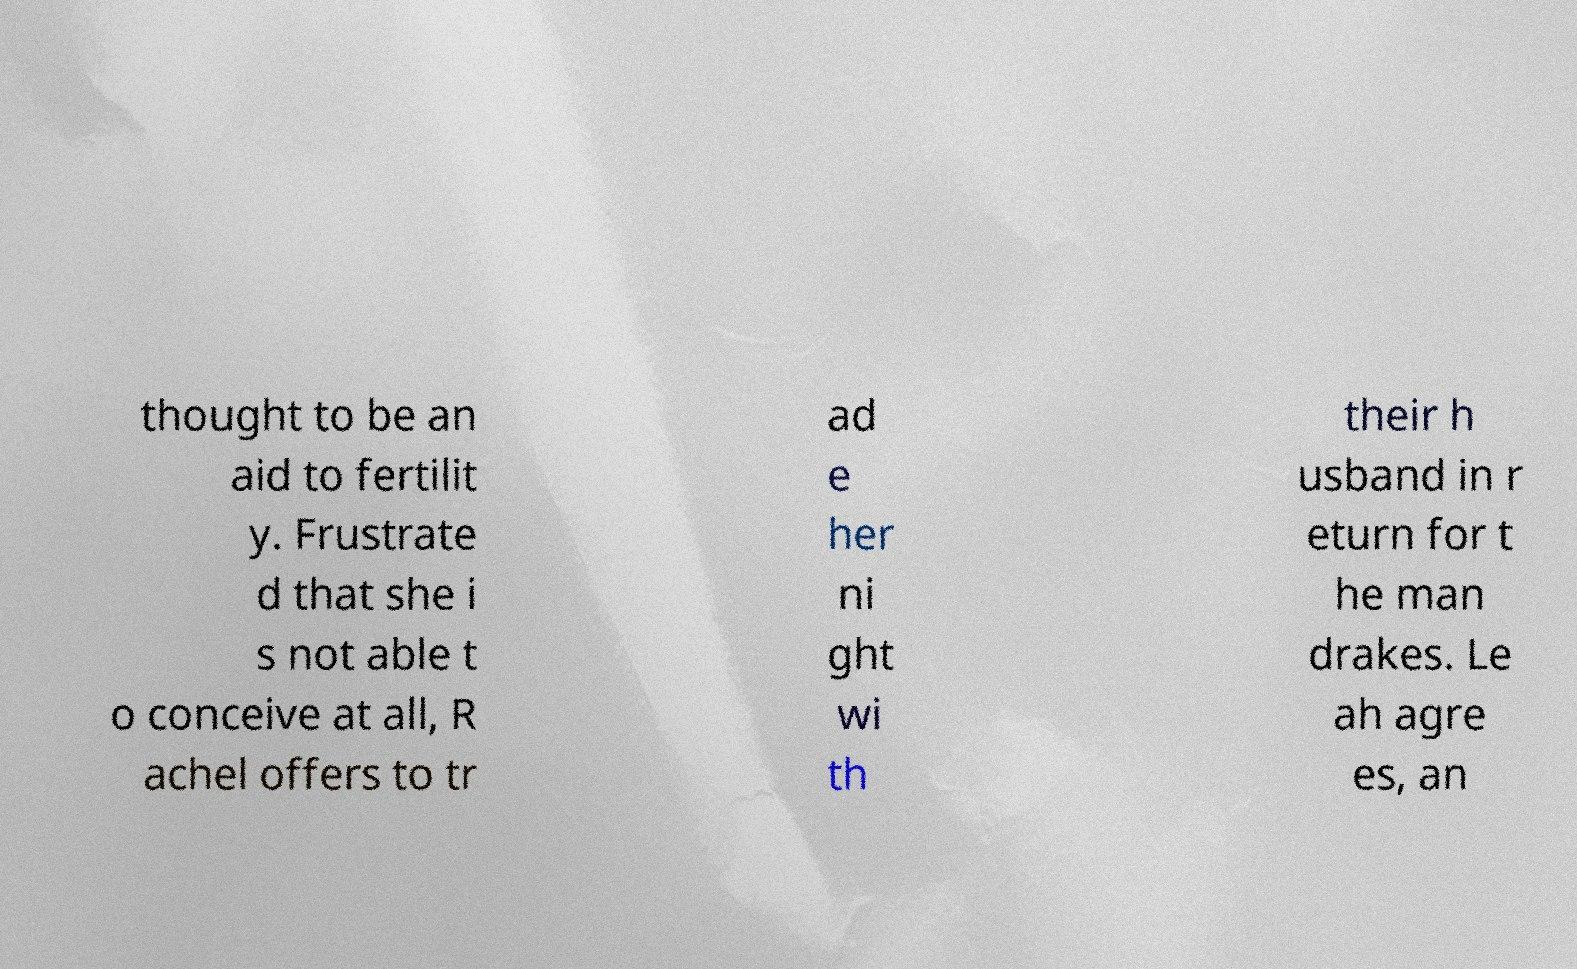What messages or text are displayed in this image? I need them in a readable, typed format. thought to be an aid to fertilit y. Frustrate d that she i s not able t o conceive at all, R achel offers to tr ad e her ni ght wi th their h usband in r eturn for t he man drakes. Le ah agre es, an 